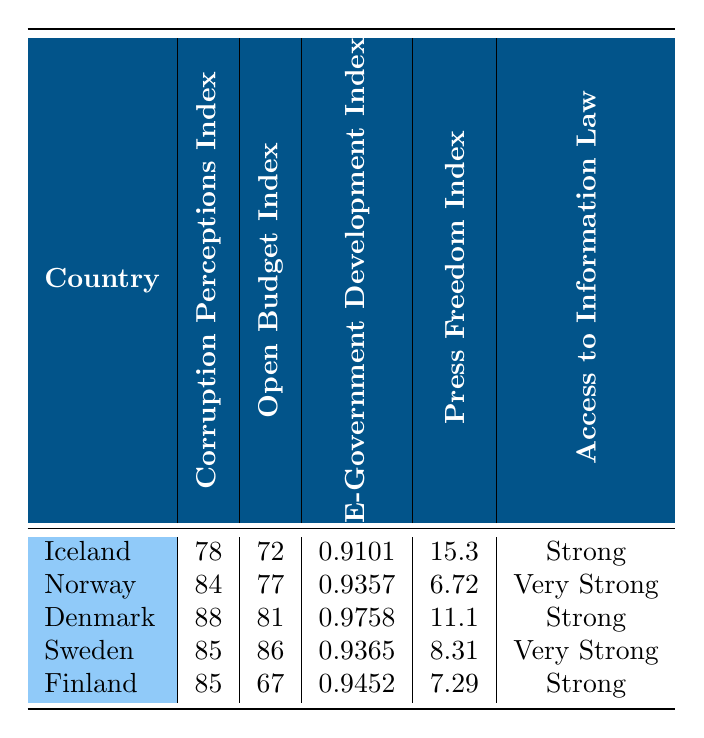What is the Corruption Perceptions Index for Denmark? The table shows that the Corruption Perceptions Index for Denmark is listed directly next to its name. The value is 88.
Answer: 88 Which country has the highest Open Budget Index? By looking at the Open Budget Index values in the table, Denmark has the highest value at 81, and all other countries have lower scores.
Answer: Denmark Is Finland's Access to Information Law classified as "Very Strong"? The table states Finland's Access to Information Law is classified as "Strong," not "Very Strong," based on the qualitative assessment provided.
Answer: No What is the average E-Government Development Index of the Nordic countries listed? To find the average, sum the E-Government Development Index values: (0.9101 + 0.9357 + 0.9758 + 0.9365 + 0.9452) = 4.7033. Then divide by the total number of countries (5): 4.7033 / 5 = 0.94066.
Answer: 0.94066 Which country has the worst Press Freedom Index score? The Press Freedom Index reflects the scores listed in the table; the highest number of 15.3 indicates the worst score of press freedom. That score belongs to Iceland.
Answer: Iceland Does Norway have a higher Corruption Perceptions Index than Sweden? The table displays Norway's index as 84 and Sweden's as 85. Since 84 is less than 85, it indicates that Norway does not have a higher index than Sweden.
Answer: No How does Iceland's Open Budget Index compare to Finland’s? Iceland's Open Budget Index is 72, while Finland's is 67. This comparison shows that Iceland has a higher index by 5 points.
Answer: Iceland is higher by 5 Which country's E-Government Development Index is closest to 0.95? Evaluating the E-Government Development Index values, Finland's index at 0.9452 is the closest to 0.95.
Answer: Finland Is the average Corruption Perceptions Index of all countries over 80? The values are 78 for Iceland, 84 for Norway, 88 for Denmark, 85 for Sweden, and 85 for Finland. Summing these gives 78 + 84 + 88 + 85 + 85 = 420. Dividing by 5 yields an average of 84. Therefore, the average is over 80.
Answer: Yes 